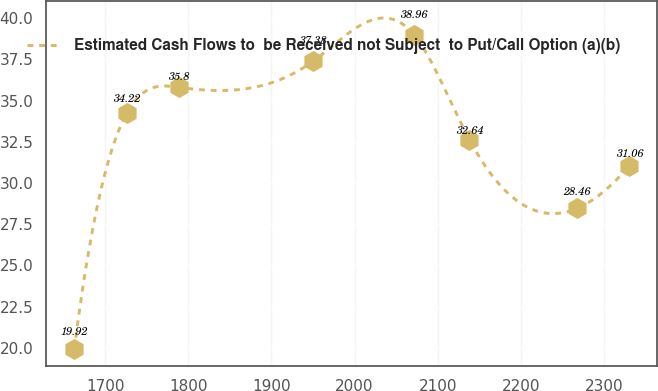Convert chart to OTSL. <chart><loc_0><loc_0><loc_500><loc_500><line_chart><ecel><fcel>Estimated Cash Flows to  be Received not Subject  to Put/Call Option (a)(b)<nl><fcel>1662.71<fcel>19.92<nl><fcel>1725.86<fcel>34.22<nl><fcel>1789.01<fcel>35.8<nl><fcel>1949.91<fcel>37.38<nl><fcel>2072.01<fcel>38.96<nl><fcel>2138.14<fcel>32.64<nl><fcel>2267.68<fcel>28.46<nl><fcel>2330.83<fcel>31.06<nl></chart> 